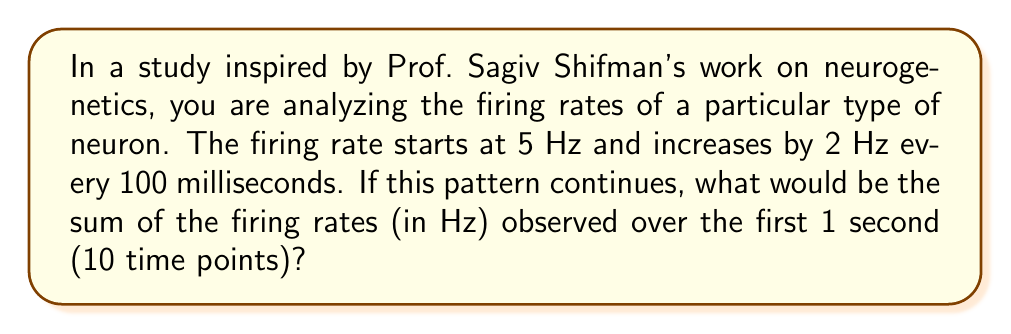Could you help me with this problem? Let's approach this step-by-step:

1) First, we need to identify the components of our arithmetic sequence:
   - $a_1 = 5$ Hz (first term)
   - $d = 2$ Hz (common difference)
   - $n = 10$ (number of terms, as there are 10 time points in 1 second)

2) The arithmetic sequence will be:
   5, 7, 9, 11, 13, 15, 17, 19, 21, 23

3) We need to find the partial sum of this sequence. The formula for the partial sum of an arithmetic sequence is:

   $$S_n = \frac{n}{2}(a_1 + a_n)$$

   where $S_n$ is the sum of the first $n$ terms, $a_1$ is the first term, and $a_n$ is the last term.

4) We know $a_1 = 5$, but we need to calculate $a_n$:
   
   $a_n = a_1 + (n-1)d = 5 + (10-1)2 = 5 + 18 = 23$

5) Now we can apply the formula:

   $$S_{10} = \frac{10}{2}(5 + 23) = 5(28) = 140$$

Therefore, the sum of the firing rates over the first second is 140 Hz.
Answer: 140 Hz 